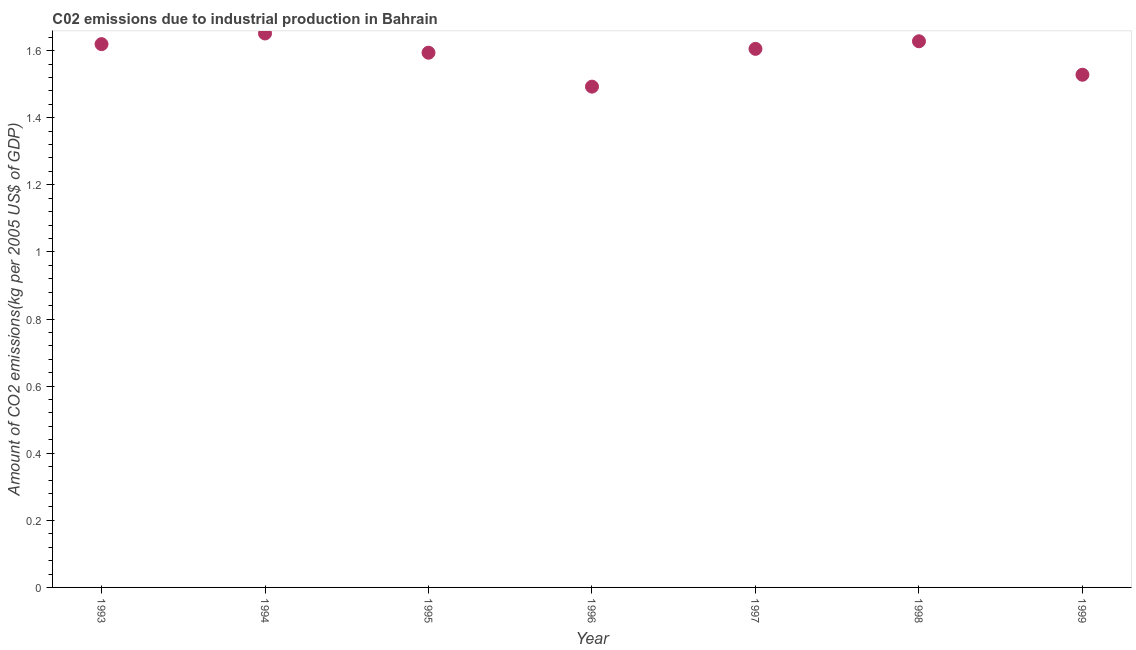What is the amount of co2 emissions in 1995?
Your answer should be compact. 1.59. Across all years, what is the maximum amount of co2 emissions?
Provide a succinct answer. 1.65. Across all years, what is the minimum amount of co2 emissions?
Give a very brief answer. 1.49. In which year was the amount of co2 emissions maximum?
Provide a succinct answer. 1994. What is the sum of the amount of co2 emissions?
Make the answer very short. 11.12. What is the difference between the amount of co2 emissions in 1995 and 1998?
Provide a short and direct response. -0.03. What is the average amount of co2 emissions per year?
Offer a very short reply. 1.59. What is the median amount of co2 emissions?
Provide a succinct answer. 1.61. Do a majority of the years between 1998 and 1995 (inclusive) have amount of co2 emissions greater than 1.2800000000000002 kg per 2005 US$ of GDP?
Provide a succinct answer. Yes. What is the ratio of the amount of co2 emissions in 1994 to that in 1999?
Provide a short and direct response. 1.08. Is the amount of co2 emissions in 1996 less than that in 1997?
Provide a succinct answer. Yes. What is the difference between the highest and the second highest amount of co2 emissions?
Provide a succinct answer. 0.02. Is the sum of the amount of co2 emissions in 1996 and 1998 greater than the maximum amount of co2 emissions across all years?
Provide a succinct answer. Yes. What is the difference between the highest and the lowest amount of co2 emissions?
Your answer should be very brief. 0.16. In how many years, is the amount of co2 emissions greater than the average amount of co2 emissions taken over all years?
Make the answer very short. 5. Are the values on the major ticks of Y-axis written in scientific E-notation?
Your answer should be compact. No. Does the graph contain any zero values?
Provide a succinct answer. No. What is the title of the graph?
Keep it short and to the point. C02 emissions due to industrial production in Bahrain. What is the label or title of the Y-axis?
Your answer should be very brief. Amount of CO2 emissions(kg per 2005 US$ of GDP). What is the Amount of CO2 emissions(kg per 2005 US$ of GDP) in 1993?
Provide a short and direct response. 1.62. What is the Amount of CO2 emissions(kg per 2005 US$ of GDP) in 1994?
Offer a terse response. 1.65. What is the Amount of CO2 emissions(kg per 2005 US$ of GDP) in 1995?
Your answer should be very brief. 1.59. What is the Amount of CO2 emissions(kg per 2005 US$ of GDP) in 1996?
Keep it short and to the point. 1.49. What is the Amount of CO2 emissions(kg per 2005 US$ of GDP) in 1997?
Offer a terse response. 1.61. What is the Amount of CO2 emissions(kg per 2005 US$ of GDP) in 1998?
Offer a very short reply. 1.63. What is the Amount of CO2 emissions(kg per 2005 US$ of GDP) in 1999?
Offer a very short reply. 1.53. What is the difference between the Amount of CO2 emissions(kg per 2005 US$ of GDP) in 1993 and 1994?
Give a very brief answer. -0.03. What is the difference between the Amount of CO2 emissions(kg per 2005 US$ of GDP) in 1993 and 1995?
Your answer should be very brief. 0.03. What is the difference between the Amount of CO2 emissions(kg per 2005 US$ of GDP) in 1993 and 1996?
Your answer should be very brief. 0.13. What is the difference between the Amount of CO2 emissions(kg per 2005 US$ of GDP) in 1993 and 1997?
Offer a terse response. 0.01. What is the difference between the Amount of CO2 emissions(kg per 2005 US$ of GDP) in 1993 and 1998?
Your response must be concise. -0.01. What is the difference between the Amount of CO2 emissions(kg per 2005 US$ of GDP) in 1993 and 1999?
Provide a succinct answer. 0.09. What is the difference between the Amount of CO2 emissions(kg per 2005 US$ of GDP) in 1994 and 1995?
Your response must be concise. 0.06. What is the difference between the Amount of CO2 emissions(kg per 2005 US$ of GDP) in 1994 and 1996?
Your answer should be very brief. 0.16. What is the difference between the Amount of CO2 emissions(kg per 2005 US$ of GDP) in 1994 and 1997?
Your response must be concise. 0.05. What is the difference between the Amount of CO2 emissions(kg per 2005 US$ of GDP) in 1994 and 1998?
Keep it short and to the point. 0.02. What is the difference between the Amount of CO2 emissions(kg per 2005 US$ of GDP) in 1994 and 1999?
Your answer should be very brief. 0.12. What is the difference between the Amount of CO2 emissions(kg per 2005 US$ of GDP) in 1995 and 1996?
Your answer should be compact. 0.1. What is the difference between the Amount of CO2 emissions(kg per 2005 US$ of GDP) in 1995 and 1997?
Your response must be concise. -0.01. What is the difference between the Amount of CO2 emissions(kg per 2005 US$ of GDP) in 1995 and 1998?
Provide a succinct answer. -0.03. What is the difference between the Amount of CO2 emissions(kg per 2005 US$ of GDP) in 1995 and 1999?
Give a very brief answer. 0.07. What is the difference between the Amount of CO2 emissions(kg per 2005 US$ of GDP) in 1996 and 1997?
Your response must be concise. -0.11. What is the difference between the Amount of CO2 emissions(kg per 2005 US$ of GDP) in 1996 and 1998?
Offer a very short reply. -0.14. What is the difference between the Amount of CO2 emissions(kg per 2005 US$ of GDP) in 1996 and 1999?
Make the answer very short. -0.04. What is the difference between the Amount of CO2 emissions(kg per 2005 US$ of GDP) in 1997 and 1998?
Provide a succinct answer. -0.02. What is the difference between the Amount of CO2 emissions(kg per 2005 US$ of GDP) in 1997 and 1999?
Keep it short and to the point. 0.08. What is the difference between the Amount of CO2 emissions(kg per 2005 US$ of GDP) in 1998 and 1999?
Your answer should be compact. 0.1. What is the ratio of the Amount of CO2 emissions(kg per 2005 US$ of GDP) in 1993 to that in 1995?
Provide a short and direct response. 1.02. What is the ratio of the Amount of CO2 emissions(kg per 2005 US$ of GDP) in 1993 to that in 1996?
Provide a short and direct response. 1.08. What is the ratio of the Amount of CO2 emissions(kg per 2005 US$ of GDP) in 1993 to that in 1998?
Your answer should be compact. 0.99. What is the ratio of the Amount of CO2 emissions(kg per 2005 US$ of GDP) in 1993 to that in 1999?
Give a very brief answer. 1.06. What is the ratio of the Amount of CO2 emissions(kg per 2005 US$ of GDP) in 1994 to that in 1995?
Offer a very short reply. 1.04. What is the ratio of the Amount of CO2 emissions(kg per 2005 US$ of GDP) in 1994 to that in 1996?
Make the answer very short. 1.11. What is the ratio of the Amount of CO2 emissions(kg per 2005 US$ of GDP) in 1995 to that in 1996?
Offer a very short reply. 1.07. What is the ratio of the Amount of CO2 emissions(kg per 2005 US$ of GDP) in 1995 to that in 1997?
Offer a terse response. 0.99. What is the ratio of the Amount of CO2 emissions(kg per 2005 US$ of GDP) in 1995 to that in 1998?
Keep it short and to the point. 0.98. What is the ratio of the Amount of CO2 emissions(kg per 2005 US$ of GDP) in 1995 to that in 1999?
Provide a short and direct response. 1.04. What is the ratio of the Amount of CO2 emissions(kg per 2005 US$ of GDP) in 1996 to that in 1997?
Give a very brief answer. 0.93. What is the ratio of the Amount of CO2 emissions(kg per 2005 US$ of GDP) in 1996 to that in 1998?
Provide a short and direct response. 0.92. What is the ratio of the Amount of CO2 emissions(kg per 2005 US$ of GDP) in 1996 to that in 1999?
Provide a succinct answer. 0.98. What is the ratio of the Amount of CO2 emissions(kg per 2005 US$ of GDP) in 1997 to that in 1998?
Keep it short and to the point. 0.99. What is the ratio of the Amount of CO2 emissions(kg per 2005 US$ of GDP) in 1997 to that in 1999?
Give a very brief answer. 1.05. What is the ratio of the Amount of CO2 emissions(kg per 2005 US$ of GDP) in 1998 to that in 1999?
Ensure brevity in your answer.  1.06. 